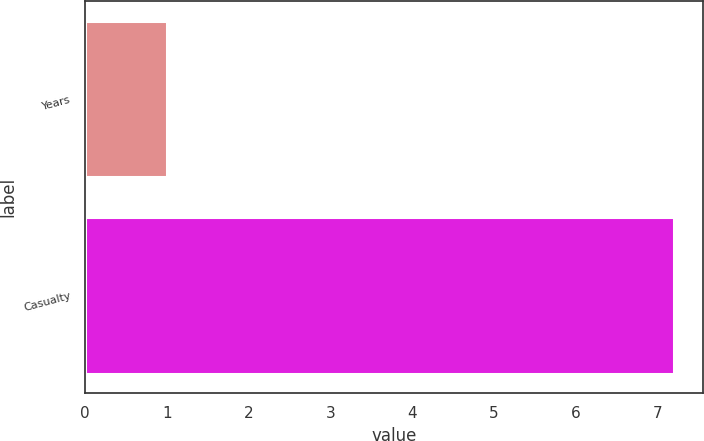Convert chart to OTSL. <chart><loc_0><loc_0><loc_500><loc_500><bar_chart><fcel>Years<fcel>Casualty<nl><fcel>1<fcel>7.2<nl></chart> 